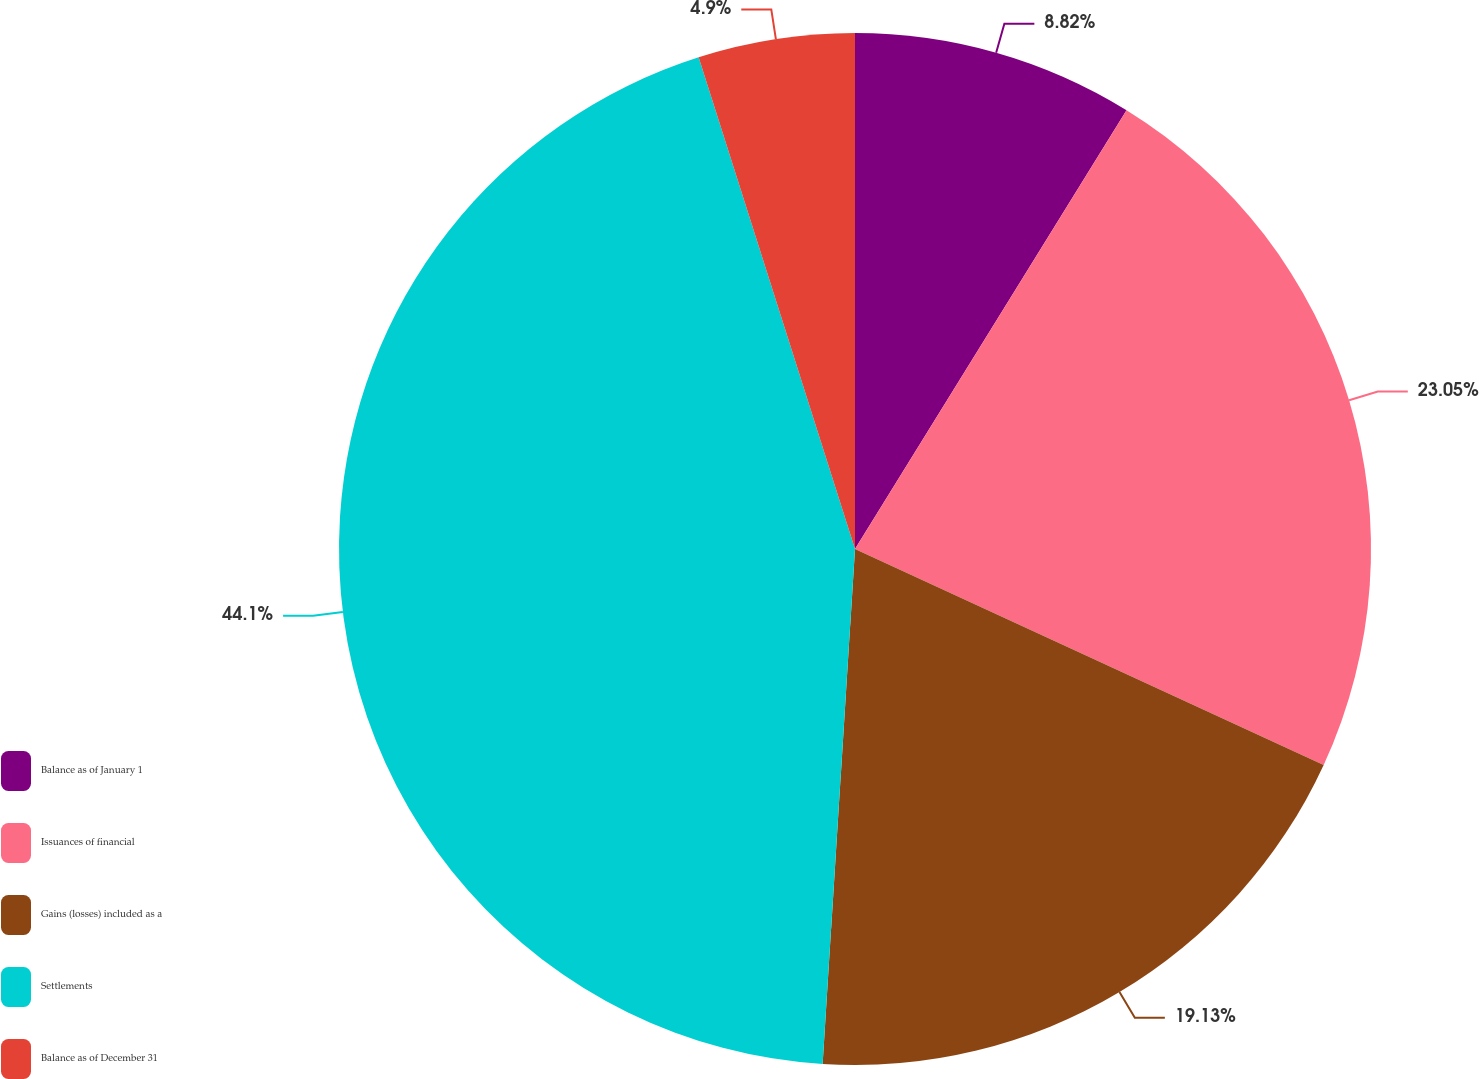Convert chart. <chart><loc_0><loc_0><loc_500><loc_500><pie_chart><fcel>Balance as of January 1<fcel>Issuances of financial<fcel>Gains (losses) included as a<fcel>Settlements<fcel>Balance as of December 31<nl><fcel>8.82%<fcel>23.05%<fcel>19.13%<fcel>44.1%<fcel>4.9%<nl></chart> 